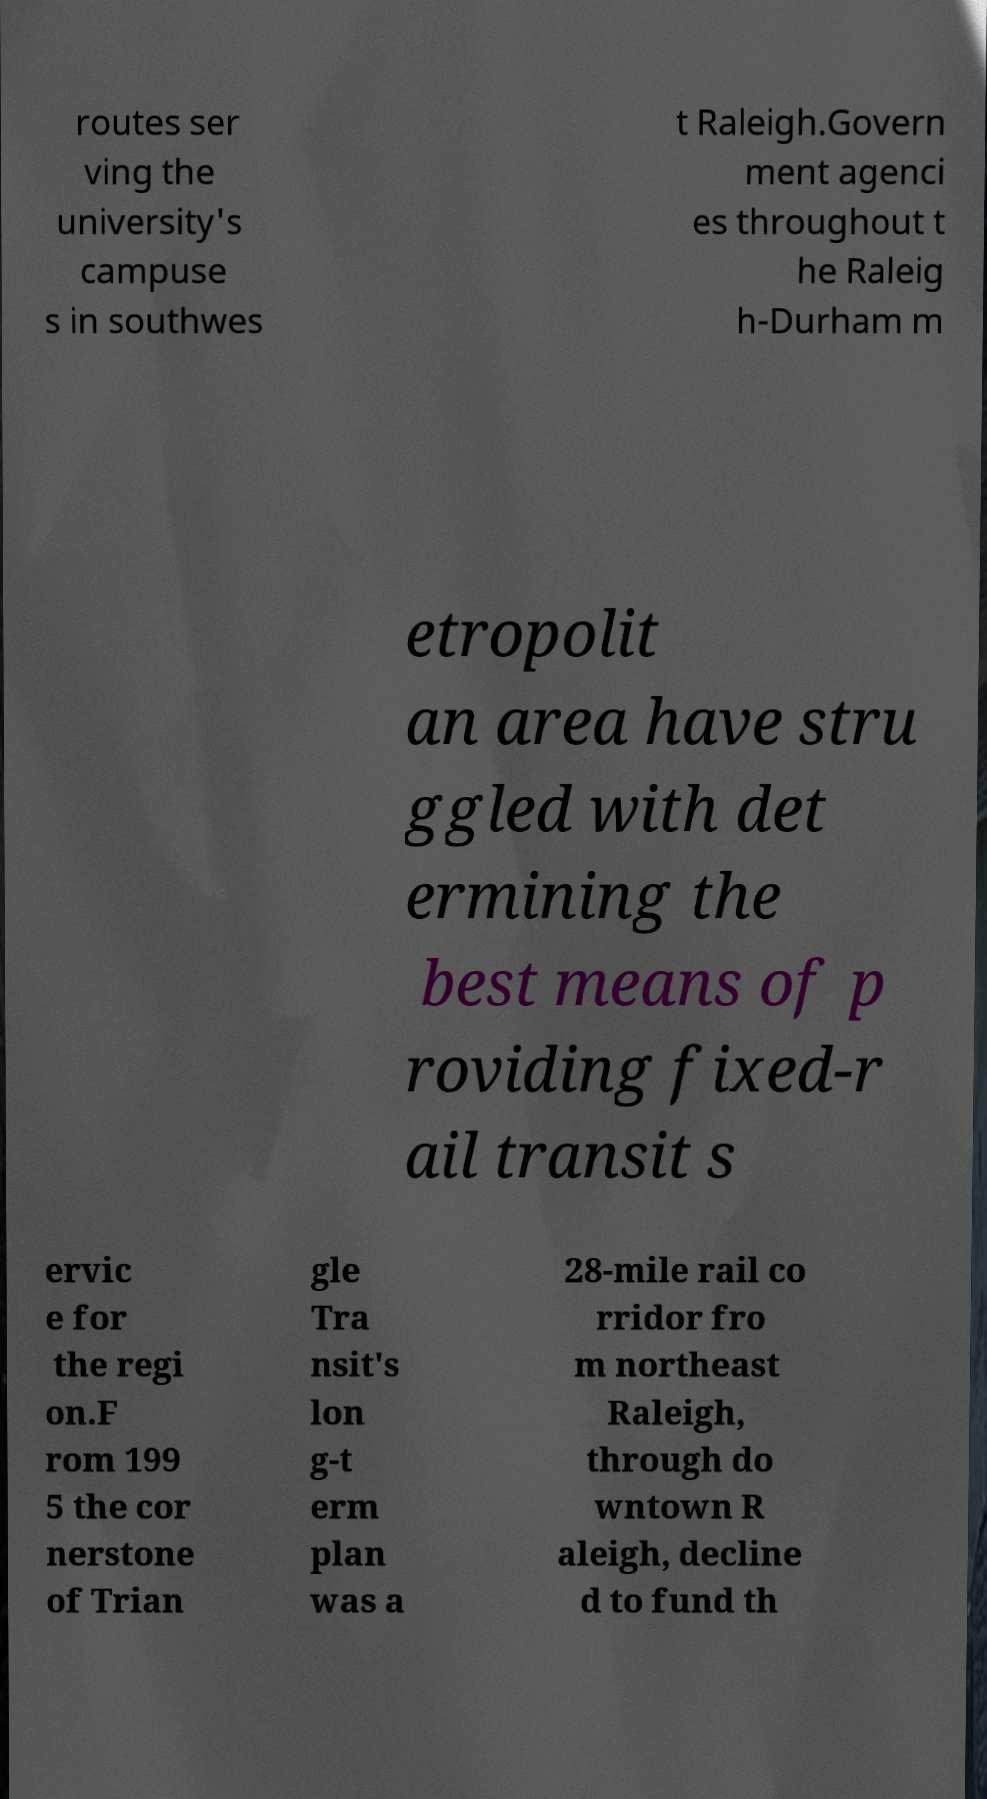There's text embedded in this image that I need extracted. Can you transcribe it verbatim? routes ser ving the university's campuse s in southwes t Raleigh.Govern ment agenci es throughout t he Raleig h-Durham m etropolit an area have stru ggled with det ermining the best means of p roviding fixed-r ail transit s ervic e for the regi on.F rom 199 5 the cor nerstone of Trian gle Tra nsit's lon g-t erm plan was a 28-mile rail co rridor fro m northeast Raleigh, through do wntown R aleigh, decline d to fund th 